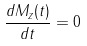Convert formula to latex. <formula><loc_0><loc_0><loc_500><loc_500>\frac { d M _ { z } ( t ) } { d t } = 0</formula> 